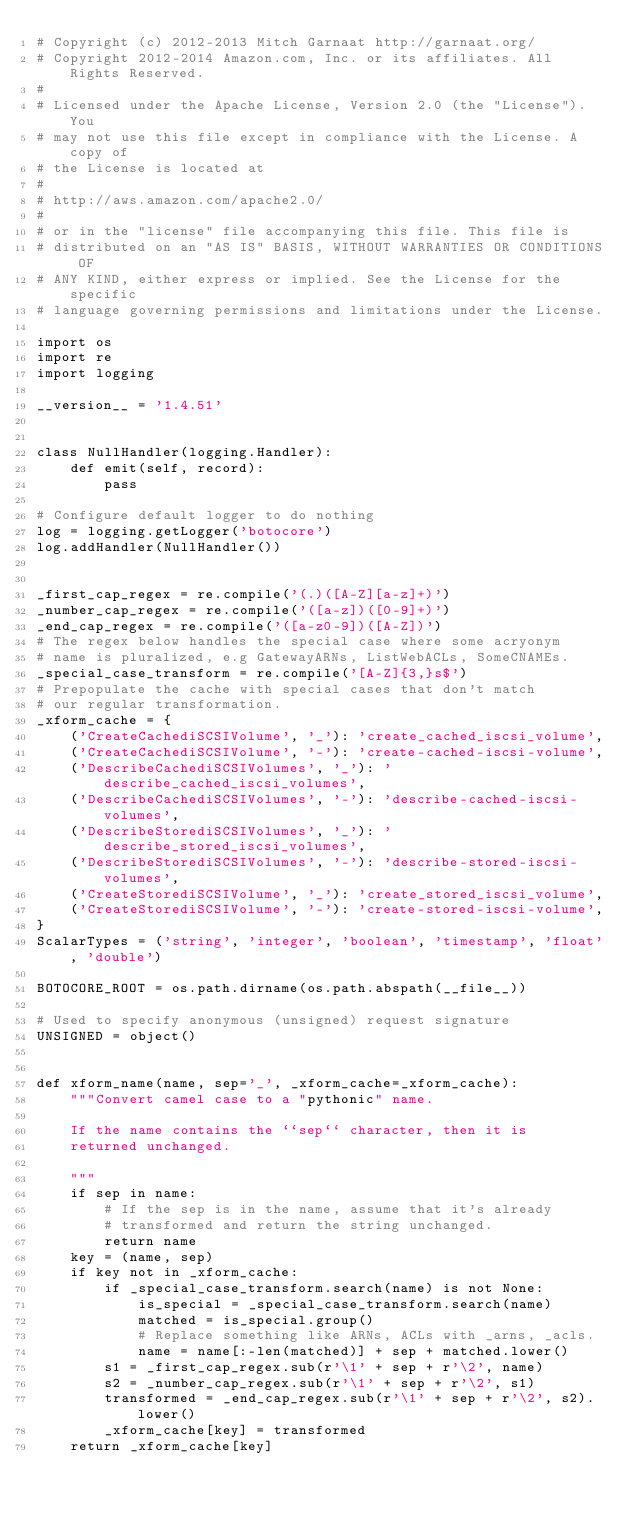Convert code to text. <code><loc_0><loc_0><loc_500><loc_500><_Python_># Copyright (c) 2012-2013 Mitch Garnaat http://garnaat.org/
# Copyright 2012-2014 Amazon.com, Inc. or its affiliates. All Rights Reserved.
#
# Licensed under the Apache License, Version 2.0 (the "License"). You
# may not use this file except in compliance with the License. A copy of
# the License is located at
#
# http://aws.amazon.com/apache2.0/
#
# or in the "license" file accompanying this file. This file is
# distributed on an "AS IS" BASIS, WITHOUT WARRANTIES OR CONDITIONS OF
# ANY KIND, either express or implied. See the License for the specific
# language governing permissions and limitations under the License.

import os
import re
import logging

__version__ = '1.4.51'


class NullHandler(logging.Handler):
    def emit(self, record):
        pass

# Configure default logger to do nothing
log = logging.getLogger('botocore')
log.addHandler(NullHandler())


_first_cap_regex = re.compile('(.)([A-Z][a-z]+)')
_number_cap_regex = re.compile('([a-z])([0-9]+)')
_end_cap_regex = re.compile('([a-z0-9])([A-Z])')
# The regex below handles the special case where some acryonym
# name is pluralized, e.g GatewayARNs, ListWebACLs, SomeCNAMEs.
_special_case_transform = re.compile('[A-Z]{3,}s$')
# Prepopulate the cache with special cases that don't match
# our regular transformation.
_xform_cache = {
    ('CreateCachediSCSIVolume', '_'): 'create_cached_iscsi_volume',
    ('CreateCachediSCSIVolume', '-'): 'create-cached-iscsi-volume',
    ('DescribeCachediSCSIVolumes', '_'): 'describe_cached_iscsi_volumes',
    ('DescribeCachediSCSIVolumes', '-'): 'describe-cached-iscsi-volumes',
    ('DescribeStorediSCSIVolumes', '_'): 'describe_stored_iscsi_volumes',
    ('DescribeStorediSCSIVolumes', '-'): 'describe-stored-iscsi-volumes',
    ('CreateStorediSCSIVolume', '_'): 'create_stored_iscsi_volume',
    ('CreateStorediSCSIVolume', '-'): 'create-stored-iscsi-volume',
}
ScalarTypes = ('string', 'integer', 'boolean', 'timestamp', 'float', 'double')

BOTOCORE_ROOT = os.path.dirname(os.path.abspath(__file__))

# Used to specify anonymous (unsigned) request signature
UNSIGNED = object()


def xform_name(name, sep='_', _xform_cache=_xform_cache):
    """Convert camel case to a "pythonic" name.

    If the name contains the ``sep`` character, then it is
    returned unchanged.

    """
    if sep in name:
        # If the sep is in the name, assume that it's already
        # transformed and return the string unchanged.
        return name
    key = (name, sep)
    if key not in _xform_cache:
        if _special_case_transform.search(name) is not None:
            is_special = _special_case_transform.search(name)
            matched = is_special.group()
            # Replace something like ARNs, ACLs with _arns, _acls.
            name = name[:-len(matched)] + sep + matched.lower()
        s1 = _first_cap_regex.sub(r'\1' + sep + r'\2', name)
        s2 = _number_cap_regex.sub(r'\1' + sep + r'\2', s1)
        transformed = _end_cap_regex.sub(r'\1' + sep + r'\2', s2).lower()
        _xform_cache[key] = transformed
    return _xform_cache[key]
</code> 